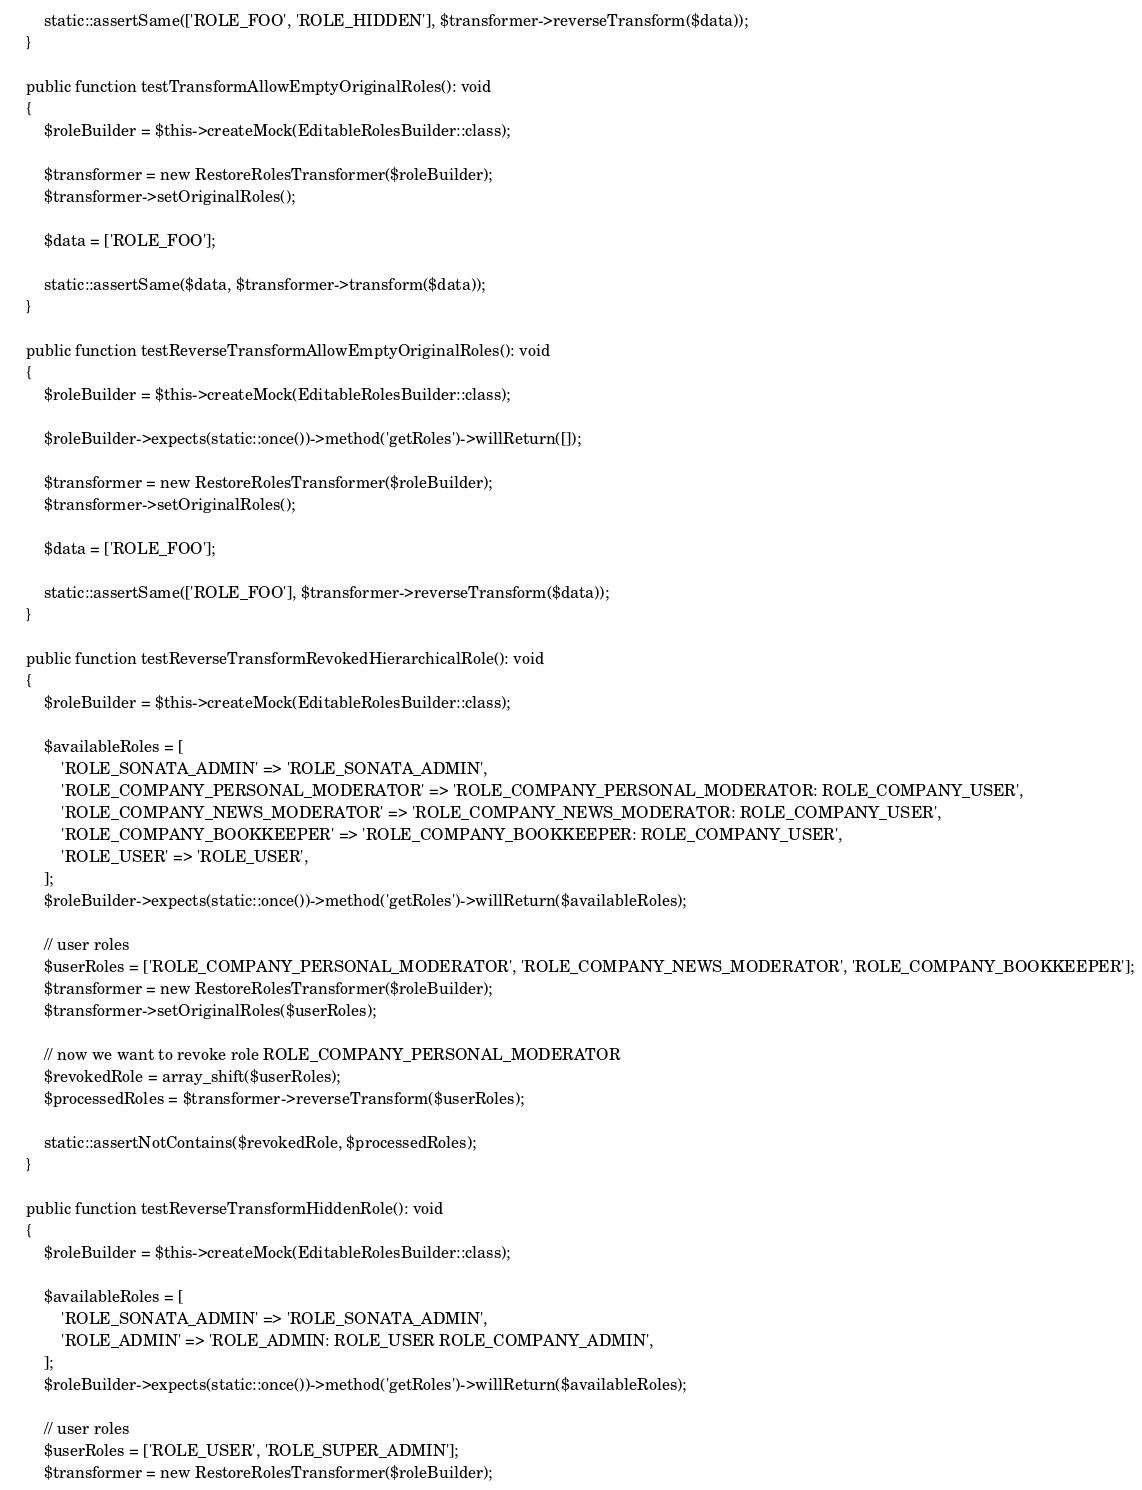<code> <loc_0><loc_0><loc_500><loc_500><_PHP_>        static::assertSame(['ROLE_FOO', 'ROLE_HIDDEN'], $transformer->reverseTransform($data));
    }

    public function testTransformAllowEmptyOriginalRoles(): void
    {
        $roleBuilder = $this->createMock(EditableRolesBuilder::class);

        $transformer = new RestoreRolesTransformer($roleBuilder);
        $transformer->setOriginalRoles();

        $data = ['ROLE_FOO'];

        static::assertSame($data, $transformer->transform($data));
    }

    public function testReverseTransformAllowEmptyOriginalRoles(): void
    {
        $roleBuilder = $this->createMock(EditableRolesBuilder::class);

        $roleBuilder->expects(static::once())->method('getRoles')->willReturn([]);

        $transformer = new RestoreRolesTransformer($roleBuilder);
        $transformer->setOriginalRoles();

        $data = ['ROLE_FOO'];

        static::assertSame(['ROLE_FOO'], $transformer->reverseTransform($data));
    }

    public function testReverseTransformRevokedHierarchicalRole(): void
    {
        $roleBuilder = $this->createMock(EditableRolesBuilder::class);

        $availableRoles = [
            'ROLE_SONATA_ADMIN' => 'ROLE_SONATA_ADMIN',
            'ROLE_COMPANY_PERSONAL_MODERATOR' => 'ROLE_COMPANY_PERSONAL_MODERATOR: ROLE_COMPANY_USER',
            'ROLE_COMPANY_NEWS_MODERATOR' => 'ROLE_COMPANY_NEWS_MODERATOR: ROLE_COMPANY_USER',
            'ROLE_COMPANY_BOOKKEEPER' => 'ROLE_COMPANY_BOOKKEEPER: ROLE_COMPANY_USER',
            'ROLE_USER' => 'ROLE_USER',
        ];
        $roleBuilder->expects(static::once())->method('getRoles')->willReturn($availableRoles);

        // user roles
        $userRoles = ['ROLE_COMPANY_PERSONAL_MODERATOR', 'ROLE_COMPANY_NEWS_MODERATOR', 'ROLE_COMPANY_BOOKKEEPER'];
        $transformer = new RestoreRolesTransformer($roleBuilder);
        $transformer->setOriginalRoles($userRoles);

        // now we want to revoke role ROLE_COMPANY_PERSONAL_MODERATOR
        $revokedRole = array_shift($userRoles);
        $processedRoles = $transformer->reverseTransform($userRoles);

        static::assertNotContains($revokedRole, $processedRoles);
    }

    public function testReverseTransformHiddenRole(): void
    {
        $roleBuilder = $this->createMock(EditableRolesBuilder::class);

        $availableRoles = [
            'ROLE_SONATA_ADMIN' => 'ROLE_SONATA_ADMIN',
            'ROLE_ADMIN' => 'ROLE_ADMIN: ROLE_USER ROLE_COMPANY_ADMIN',
        ];
        $roleBuilder->expects(static::once())->method('getRoles')->willReturn($availableRoles);

        // user roles
        $userRoles = ['ROLE_USER', 'ROLE_SUPER_ADMIN'];
        $transformer = new RestoreRolesTransformer($roleBuilder);</code> 